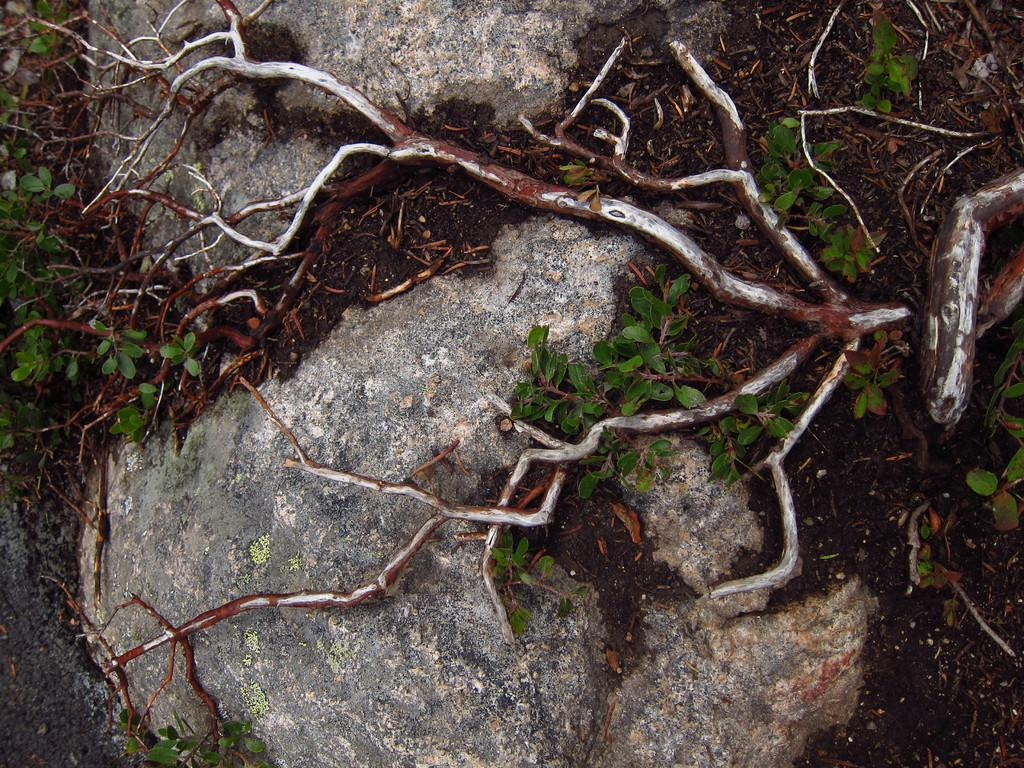What is the main subject of the image? The main subject of the image is the roots of a tree on two stones. Are there any other plants visible in the image? Yes, there are plants on the ground. Who is the expert in the image? There is no expert present in the image. What type of yam can be seen growing among the plants in the image? There is no yam present in the image; it features the roots of a tree and plants on the ground. 